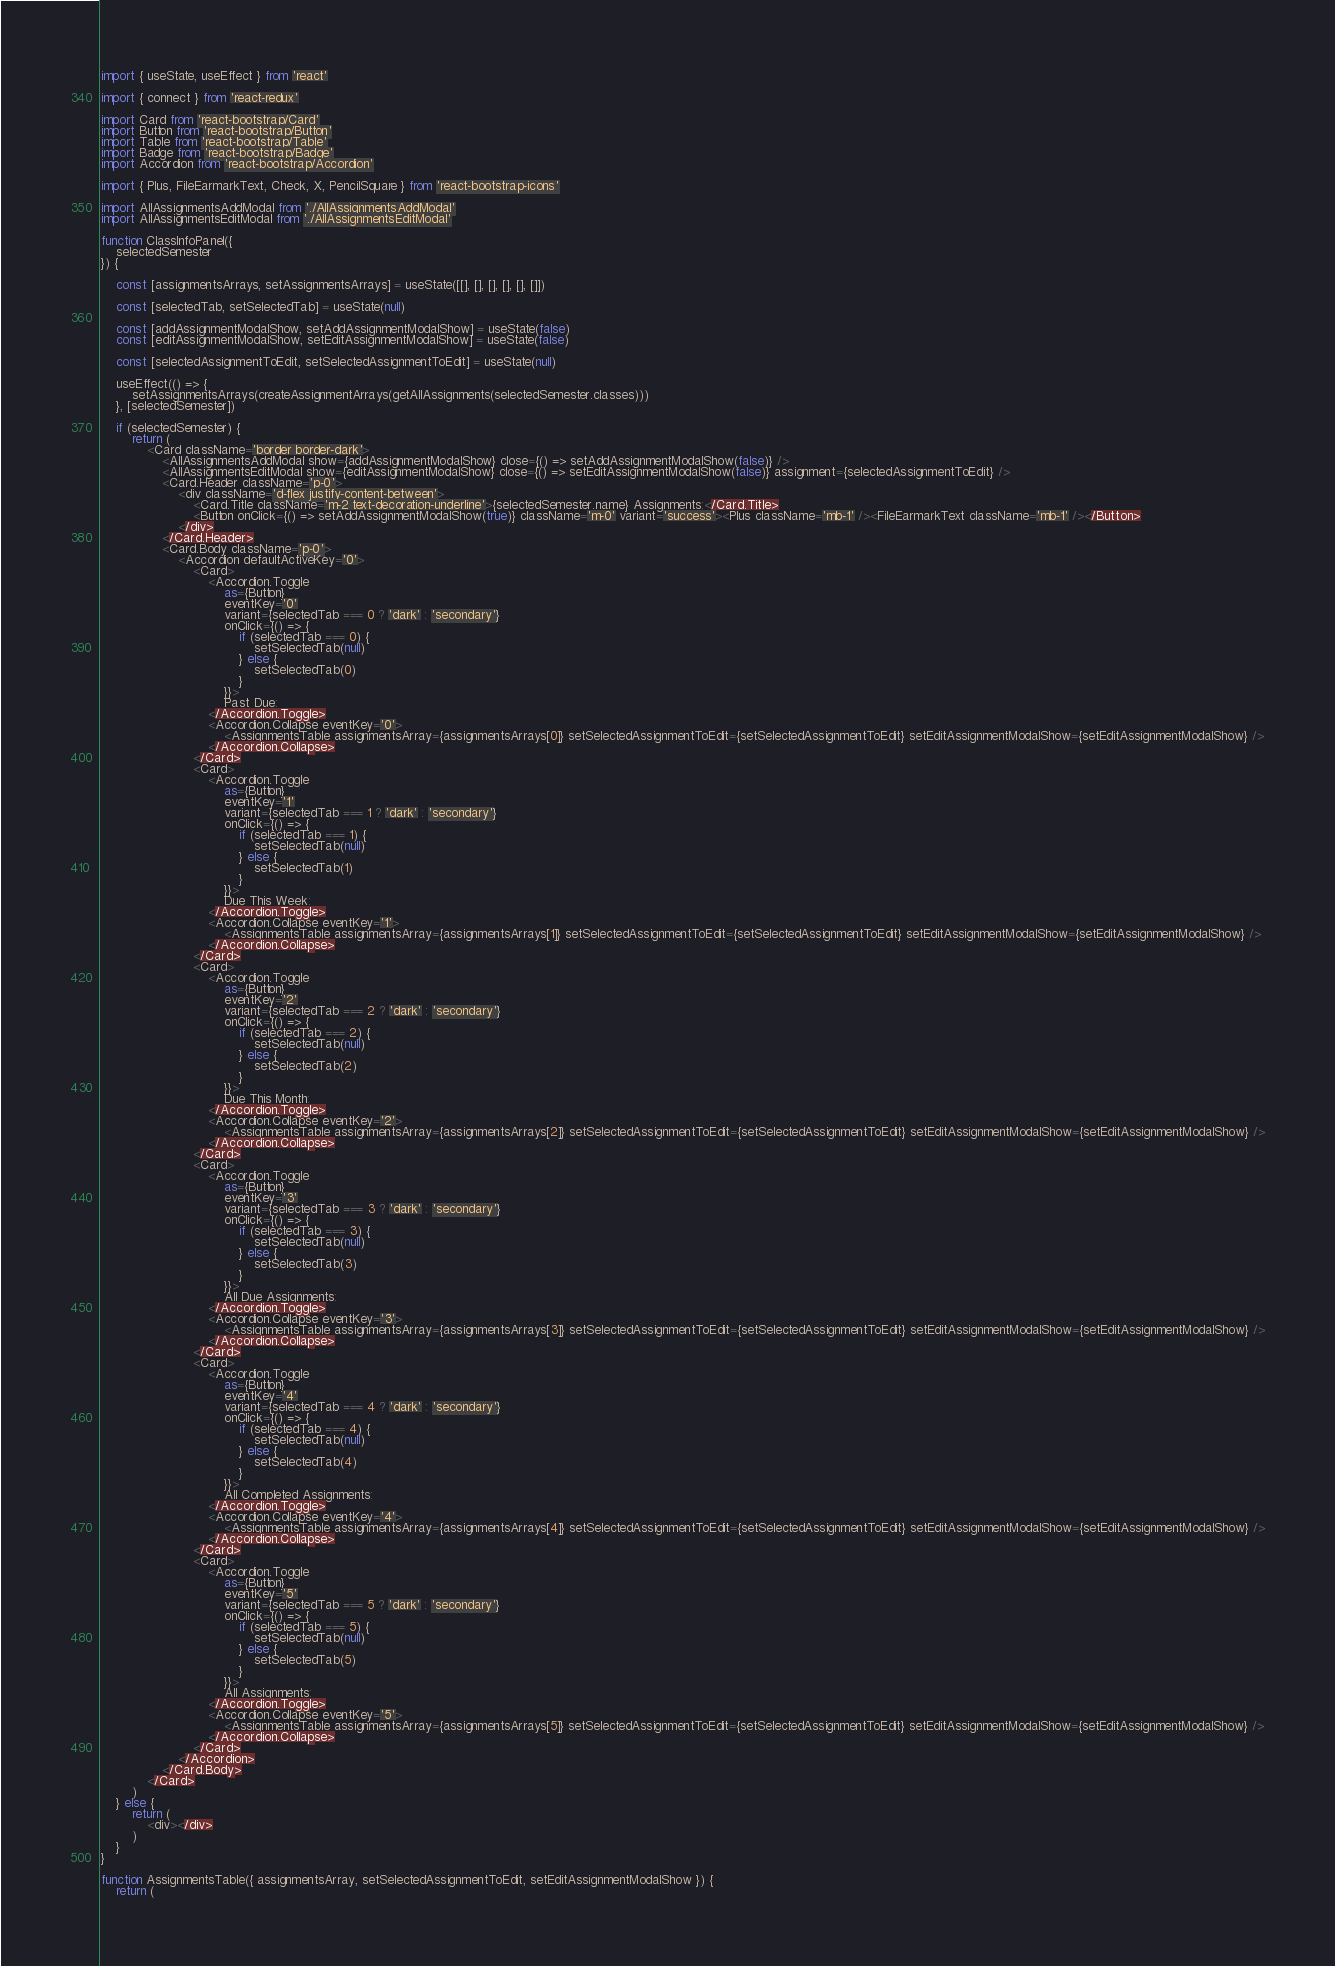Convert code to text. <code><loc_0><loc_0><loc_500><loc_500><_JavaScript_>import { useState, useEffect } from 'react'

import { connect } from 'react-redux'

import Card from 'react-bootstrap/Card'
import Button from 'react-bootstrap/Button'
import Table from 'react-bootstrap/Table'
import Badge from 'react-bootstrap/Badge'
import Accordion from 'react-bootstrap/Accordion'

import { Plus, FileEarmarkText, Check, X, PencilSquare } from 'react-bootstrap-icons'

import AllAssignmentsAddModal from './AllAssignmentsAddModal'
import AllAssignmentsEditModal from './AllAssignmentsEditModal'

function ClassInfoPanel({
    selectedSemester
}) {

    const [assignmentsArrays, setAssignmentsArrays] = useState([[], [], [], [], [], []])

    const [selectedTab, setSelectedTab] = useState(null)

    const [addAssignmentModalShow, setAddAssignmentModalShow] = useState(false)
    const [editAssignmentModalShow, setEditAssignmentModalShow] = useState(false)

    const [selectedAssignmentToEdit, setSelectedAssignmentToEdit] = useState(null)

    useEffect(() => {
        setAssignmentsArrays(createAssignmentArrays(getAllAssignments(selectedSemester.classes)))
    }, [selectedSemester])

    if (selectedSemester) {
        return (
            <Card className='border border-dark'>
                <AllAssignmentsAddModal show={addAssignmentModalShow} close={() => setAddAssignmentModalShow(false)} />
                <AllAssignmentsEditModal show={editAssignmentModalShow} close={() => setEditAssignmentModalShow(false)} assignment={selectedAssignmentToEdit} />
                <Card.Header className='p-0'>
                    <div className='d-flex justify-content-between'>
                        <Card.Title className='m-2 text-decoration-underline'>{selectedSemester.name} Assignments:</Card.Title>
                        <Button onClick={() => setAddAssignmentModalShow(true)} className='m-0' variant='success'><Plus className='mb-1' /><FileEarmarkText className='mb-1' /></Button>
                    </div>
                </Card.Header>
                <Card.Body className='p-0'>
                    <Accordion defaultActiveKey='0'>
                        <Card>
                            <Accordion.Toggle
                                as={Button}
                                eventKey='0'
                                variant={selectedTab === 0 ? 'dark' : 'secondary'}
                                onClick={() => {
                                    if (selectedTab === 0) {
                                        setSelectedTab(null)
                                    } else {
                                        setSelectedTab(0)
                                    }
                                }}>
                                Past Due:
                            </Accordion.Toggle>
                            <Accordion.Collapse eventKey='0'>
                                <AssignmentsTable assignmentsArray={assignmentsArrays[0]} setSelectedAssignmentToEdit={setSelectedAssignmentToEdit} setEditAssignmentModalShow={setEditAssignmentModalShow} />
                            </Accordion.Collapse>
                        </Card>
                        <Card>
                            <Accordion.Toggle
                                as={Button}
                                eventKey='1'
                                variant={selectedTab === 1 ? 'dark' : 'secondary'}
                                onClick={() => {
                                    if (selectedTab === 1) {
                                        setSelectedTab(null)
                                    } else {
                                        setSelectedTab(1)
                                    }
                                }}>
                                Due This Week:
                            </Accordion.Toggle>
                            <Accordion.Collapse eventKey='1'>
                                <AssignmentsTable assignmentsArray={assignmentsArrays[1]} setSelectedAssignmentToEdit={setSelectedAssignmentToEdit} setEditAssignmentModalShow={setEditAssignmentModalShow} />
                            </Accordion.Collapse>
                        </Card>
                        <Card>
                            <Accordion.Toggle
                                as={Button}
                                eventKey='2'
                                variant={selectedTab === 2 ? 'dark' : 'secondary'}
                                onClick={() => {
                                    if (selectedTab === 2) {
                                        setSelectedTab(null)
                                    } else {
                                        setSelectedTab(2)
                                    }
                                }}>
                                Due This Month:
                            </Accordion.Toggle>
                            <Accordion.Collapse eventKey='2'>
                                <AssignmentsTable assignmentsArray={assignmentsArrays[2]} setSelectedAssignmentToEdit={setSelectedAssignmentToEdit} setEditAssignmentModalShow={setEditAssignmentModalShow} />
                            </Accordion.Collapse>
                        </Card>
                        <Card>
                            <Accordion.Toggle
                                as={Button}
                                eventKey='3'
                                variant={selectedTab === 3 ? 'dark' : 'secondary'}
                                onClick={() => {
                                    if (selectedTab === 3) {
                                        setSelectedTab(null)
                                    } else {
                                        setSelectedTab(3)
                                    }
                                }}>
                                All Due Assignments:
                            </Accordion.Toggle>
                            <Accordion.Collapse eventKey='3'>
                                <AssignmentsTable assignmentsArray={assignmentsArrays[3]} setSelectedAssignmentToEdit={setSelectedAssignmentToEdit} setEditAssignmentModalShow={setEditAssignmentModalShow} />
                            </Accordion.Collapse>
                        </Card>
                        <Card>
                            <Accordion.Toggle
                                as={Button}
                                eventKey='4'
                                variant={selectedTab === 4 ? 'dark' : 'secondary'}
                                onClick={() => {
                                    if (selectedTab === 4) {
                                        setSelectedTab(null)
                                    } else {
                                        setSelectedTab(4)
                                    }
                                }}>
                                All Completed Assignments:
                            </Accordion.Toggle>
                            <Accordion.Collapse eventKey='4'>
                                <AssignmentsTable assignmentsArray={assignmentsArrays[4]} setSelectedAssignmentToEdit={setSelectedAssignmentToEdit} setEditAssignmentModalShow={setEditAssignmentModalShow} />
                            </Accordion.Collapse>
                        </Card>
                        <Card>
                            <Accordion.Toggle
                                as={Button}
                                eventKey='5'
                                variant={selectedTab === 5 ? 'dark' : 'secondary'}
                                onClick={() => {
                                    if (selectedTab === 5) {
                                        setSelectedTab(null)
                                    } else {
                                        setSelectedTab(5)
                                    }
                                }}>
                                All Assignments:
                            </Accordion.Toggle>
                            <Accordion.Collapse eventKey='5'>
                                <AssignmentsTable assignmentsArray={assignmentsArrays[5]} setSelectedAssignmentToEdit={setSelectedAssignmentToEdit} setEditAssignmentModalShow={setEditAssignmentModalShow} />
                            </Accordion.Collapse>
                        </Card>
                    </Accordion>
                </Card.Body>
            </Card>
        )
    } else {
        return (
            <div></div>
        )
    }
}

function AssignmentsTable({ assignmentsArray, setSelectedAssignmentToEdit, setEditAssignmentModalShow }) {
    return (</code> 